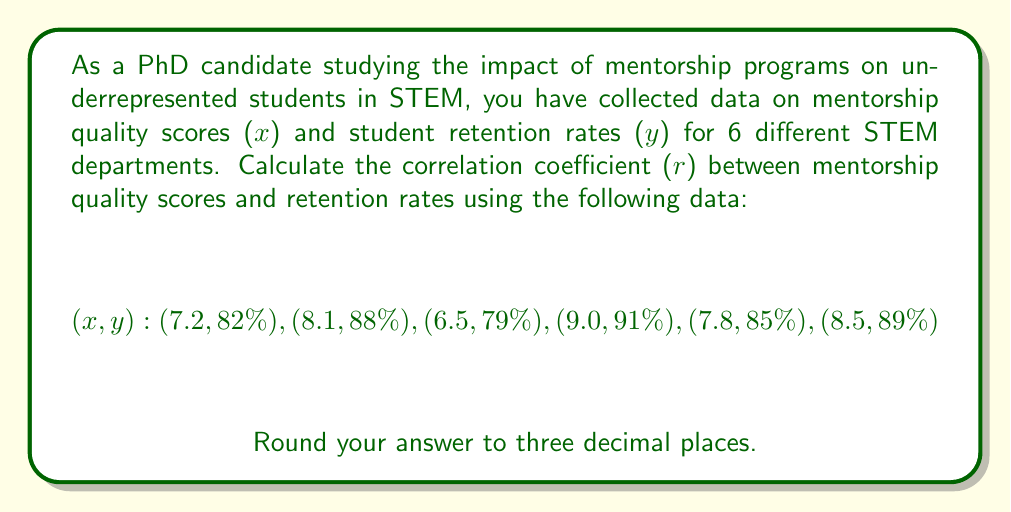Could you help me with this problem? To calculate the correlation coefficient (r), we'll use the formula:

$$r = \frac{n\sum xy - (\sum x)(\sum y)}{\sqrt{[n\sum x^2 - (\sum x)^2][n\sum y^2 - (\sum y)^2]}}$$

Where:
n = number of pairs
x = mentorship quality scores
y = retention rates (as decimals)

Step 1: Prepare the data and calculate necessary sums.
Convert percentages to decimals for y values.
Calculate $x^2$, $y^2$, and $xy$ for each pair.

| x   | y     | $x^2$ | $y^2$  | xy     |
|-----|-------|-------|--------|--------|
| 7.2 | 0.82  | 51.84 | 0.6724 | 5.9040 |
| 8.1 | 0.88  | 65.61 | 0.7744 | 7.1280 |
| 6.5 | 0.79  | 42.25 | 0.6241 | 5.1350 |
| 9.0 | 0.91  | 81.00 | 0.8281 | 8.1900 |
| 7.8 | 0.85  | 60.84 | 0.7225 | 6.6300 |
| 8.5 | 0.89  | 72.25 | 0.7921 | 7.5650 |

$\sum x = 47.1$
$\sum y = 5.14$
$\sum x^2 = 373.79$
$\sum y^2 = 4.4136$
$\sum xy = 40.5520$
n = 6

Step 2: Apply the formula.

$$r = \frac{6(40.5520) - (47.1)(5.14)}{\sqrt{[6(373.79) - (47.1)^2][6(4.4136) - (5.14)^2]}}$$

$$r = \frac{243.312 - 242.094}{\sqrt{(2242.74 - 2218.41)(26.4816 - 26.4196)}}$$

$$r = \frac{1.218}{\sqrt{(24.33)(0.062)}}$$

$$r = \frac{1.218}{\sqrt{1.50846}}$$

$$r = \frac{1.218}{1.2282}$$

$$r = 0.99169$$

Step 3: Round to three decimal places.

r = 0.992
Answer: 0.992 